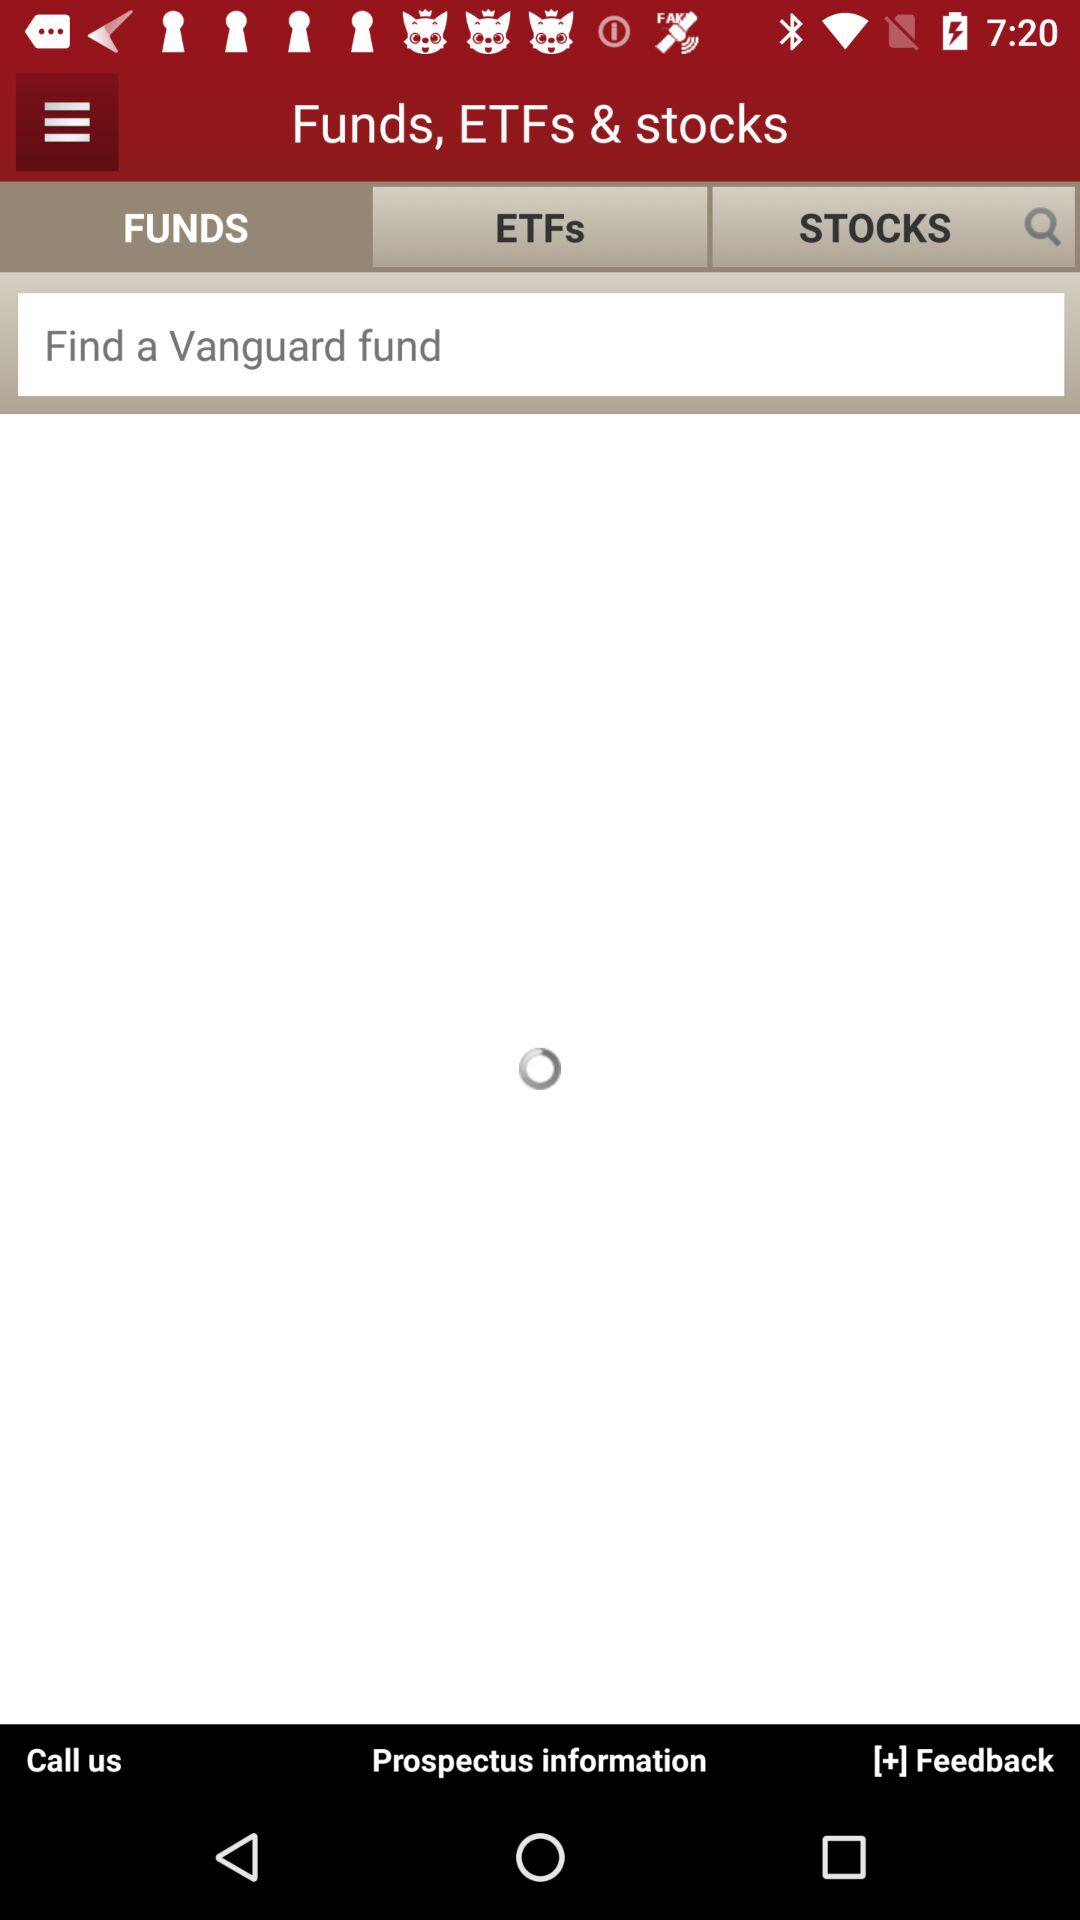Which tab is selected? The selected tab is "Funds". 